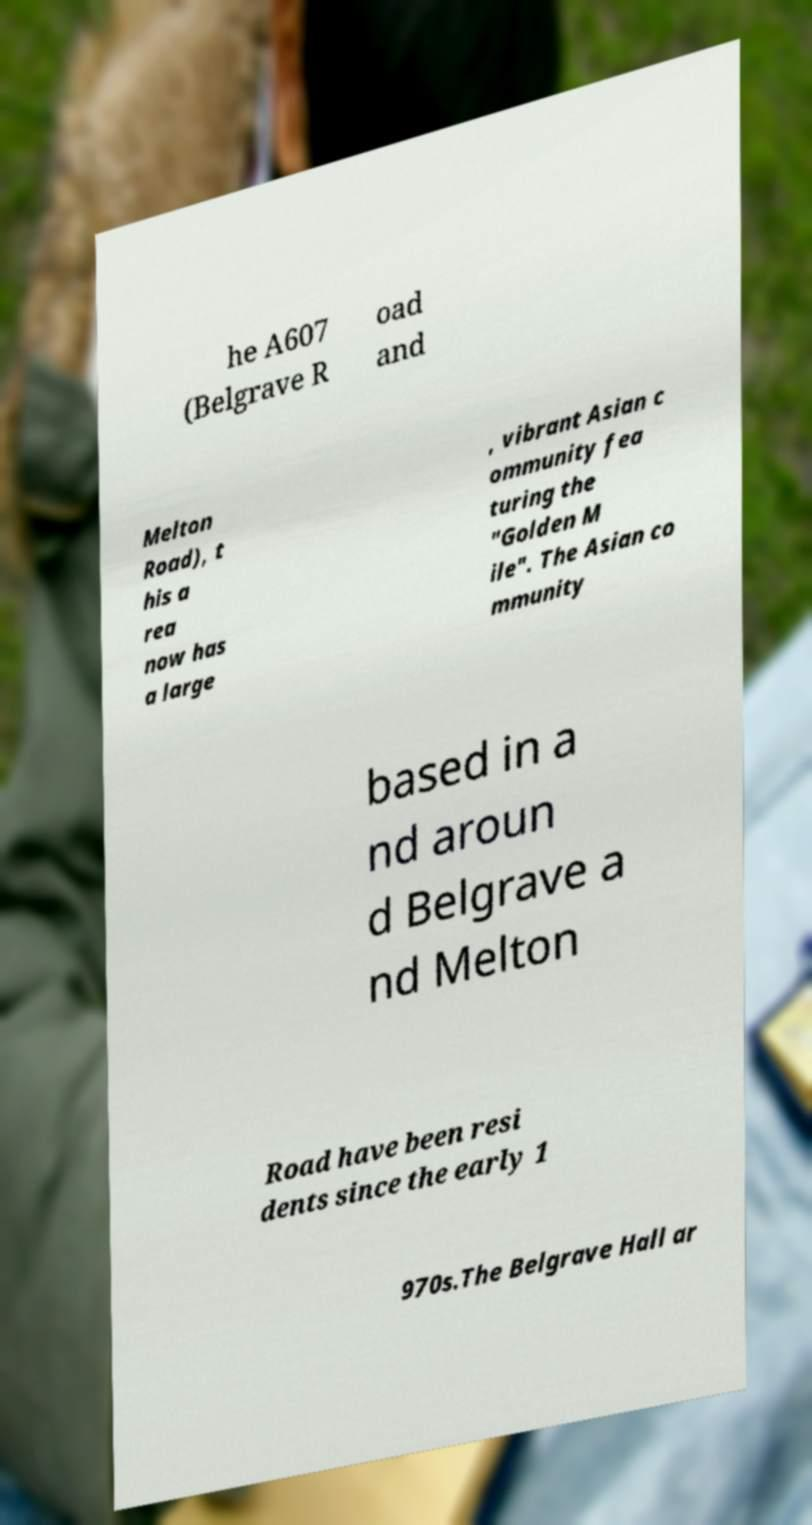For documentation purposes, I need the text within this image transcribed. Could you provide that? he A607 (Belgrave R oad and Melton Road), t his a rea now has a large , vibrant Asian c ommunity fea turing the "Golden M ile". The Asian co mmunity based in a nd aroun d Belgrave a nd Melton Road have been resi dents since the early 1 970s.The Belgrave Hall ar 